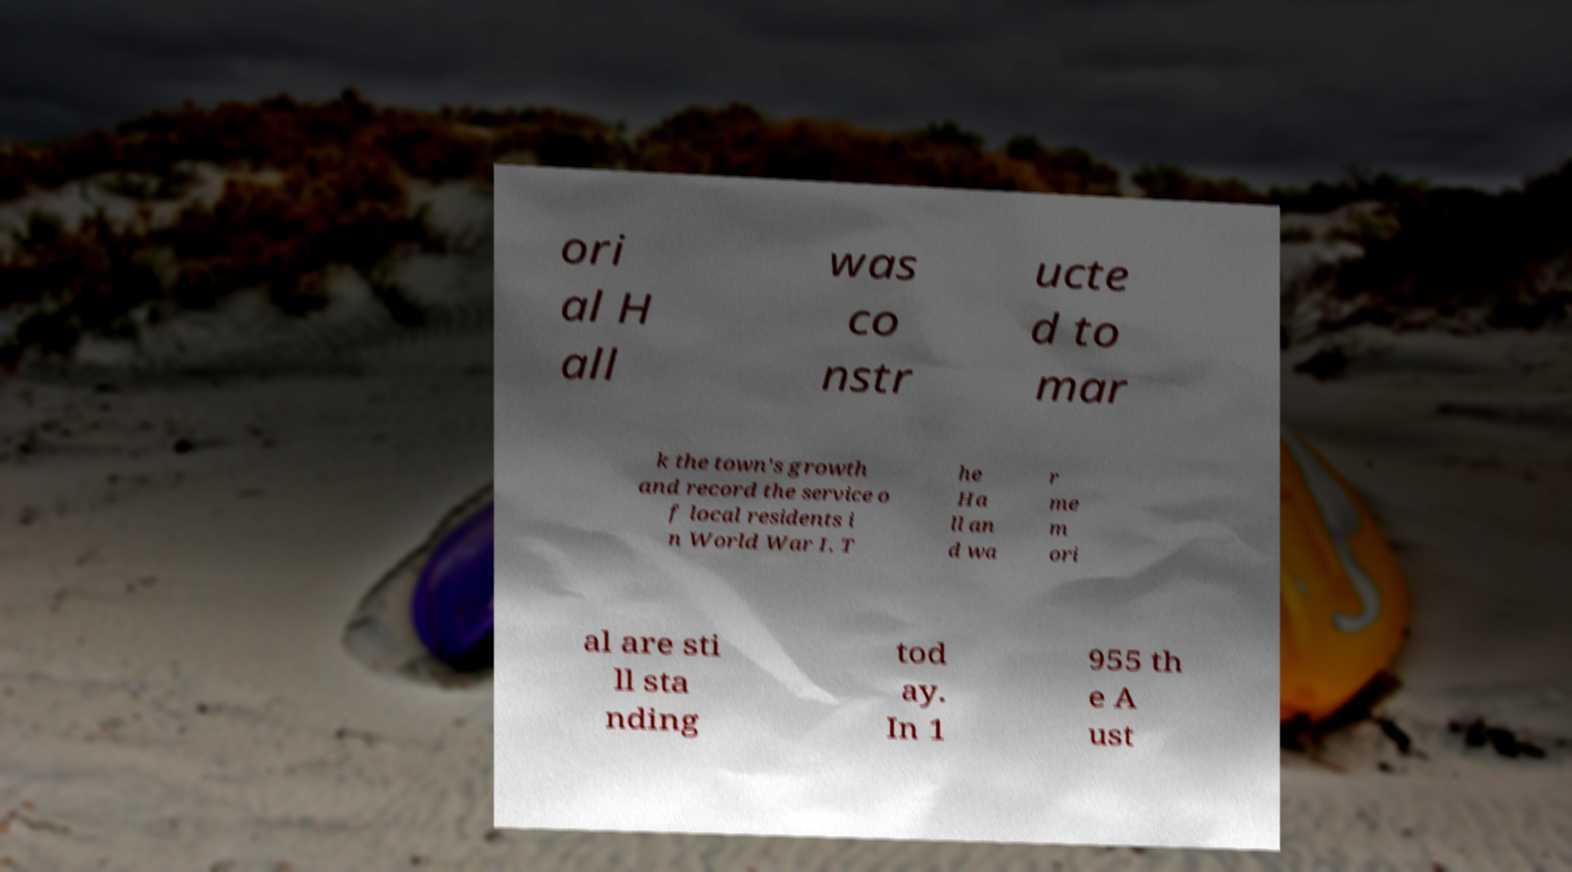Could you extract and type out the text from this image? ori al H all was co nstr ucte d to mar k the town's growth and record the service o f local residents i n World War I. T he Ha ll an d wa r me m ori al are sti ll sta nding tod ay. In 1 955 th e A ust 